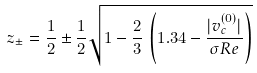<formula> <loc_0><loc_0><loc_500><loc_500>z _ { \pm } = \frac { 1 } { 2 } \pm \frac { 1 } { 2 } \sqrt { 1 - \frac { 2 } { 3 } \, \left ( 1 . 3 4 - \frac { | v _ { c } ^ { ( 0 ) } | } { \sigma R e } \right ) }</formula> 